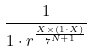Convert formula to latex. <formula><loc_0><loc_0><loc_500><loc_500>\frac { 1 } { 1 \cdot r ^ { \frac { X \times ( 1 \cdot X ) } { 7 ^ { N + 1 } } } }</formula> 